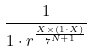Convert formula to latex. <formula><loc_0><loc_0><loc_500><loc_500>\frac { 1 } { 1 \cdot r ^ { \frac { X \times ( 1 \cdot X ) } { 7 ^ { N + 1 } } } }</formula> 